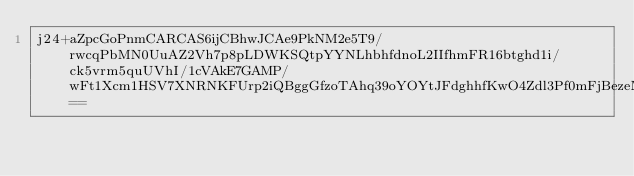<code> <loc_0><loc_0><loc_500><loc_500><_SML_>j24+aZpcGoPnmCARCAS6ijCBhwJCAe9PkNM2e5T9/rwcqPbMN0UuAZ2Vh7p8pLDWKSQtpYYNLhbhfdnoL2IIfhmFR16btghd1i/ck5vrm5quUVhI/1cVAkE7GAMP/wFt1Xcm1HSV7XNRNKFUrp2iQBggGfzoTAhq39oYOYtJFdghhfKwO4Zdl3Pf0mFjBezeMf8FNVCQus7F5w==</code> 